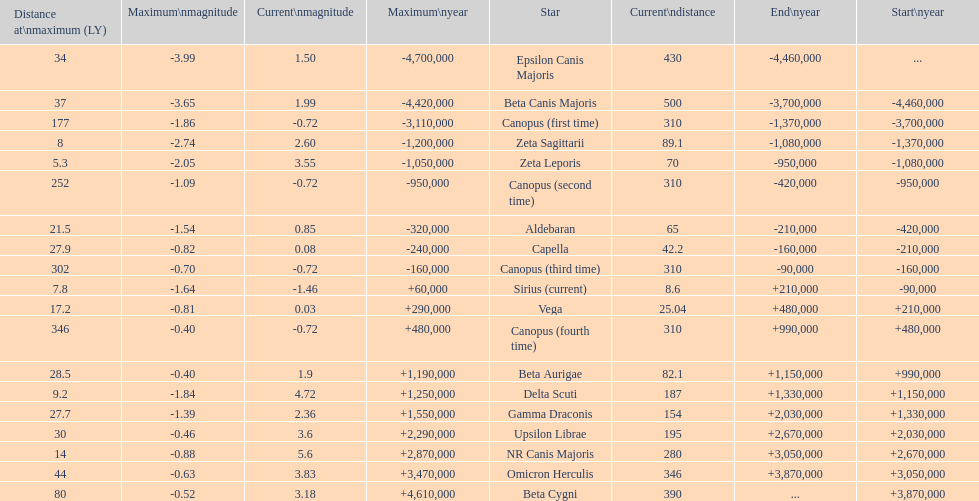At its maximum distance, which star is the most distant? Canopus (fourth time). 